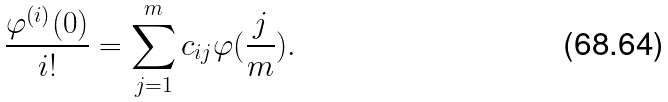Convert formula to latex. <formula><loc_0><loc_0><loc_500><loc_500>\frac { \varphi ^ { ( i ) } ( 0 ) } { i ! } = \sum _ { j = 1 } ^ { m } c _ { i j } \varphi ( \frac { j } { m } ) .</formula> 